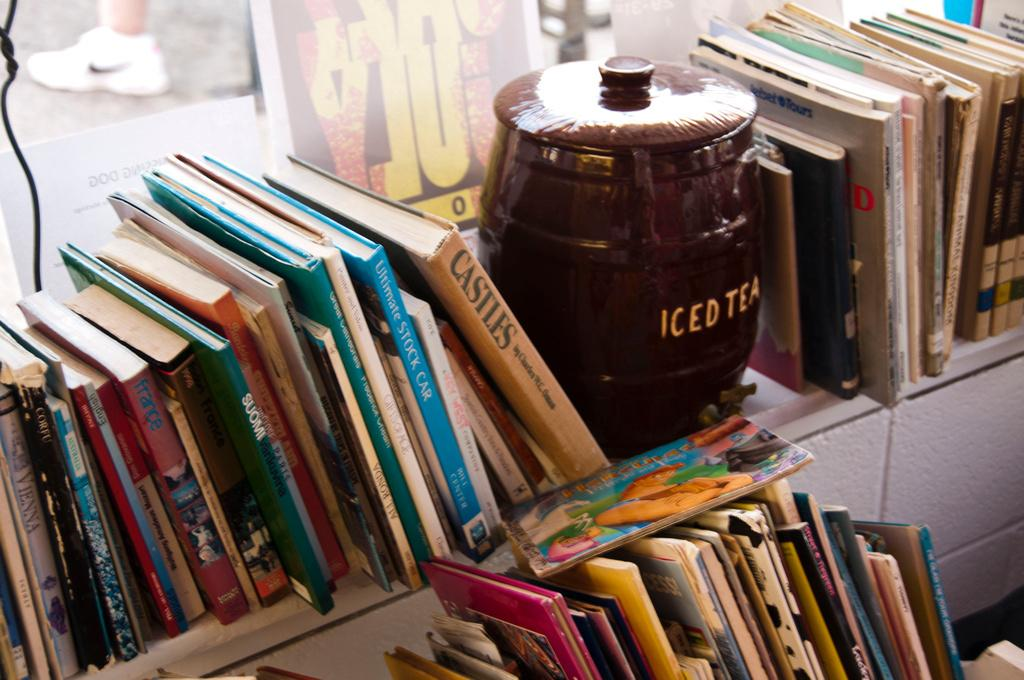<image>
Render a clear and concise summary of the photo. The shelf has books and a jar that says Iced Tea on it. 